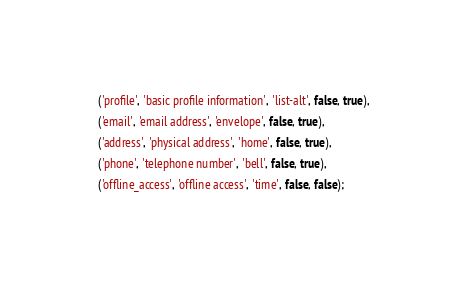<code> <loc_0><loc_0><loc_500><loc_500><_SQL_>  ('profile', 'basic profile information', 'list-alt', false, true),
  ('email', 'email address', 'envelope', false, true),
  ('address', 'physical address', 'home', false, true),
  ('phone', 'telephone number', 'bell', false, true),
  ('offline_access', 'offline access', 'time', false, false);</code> 